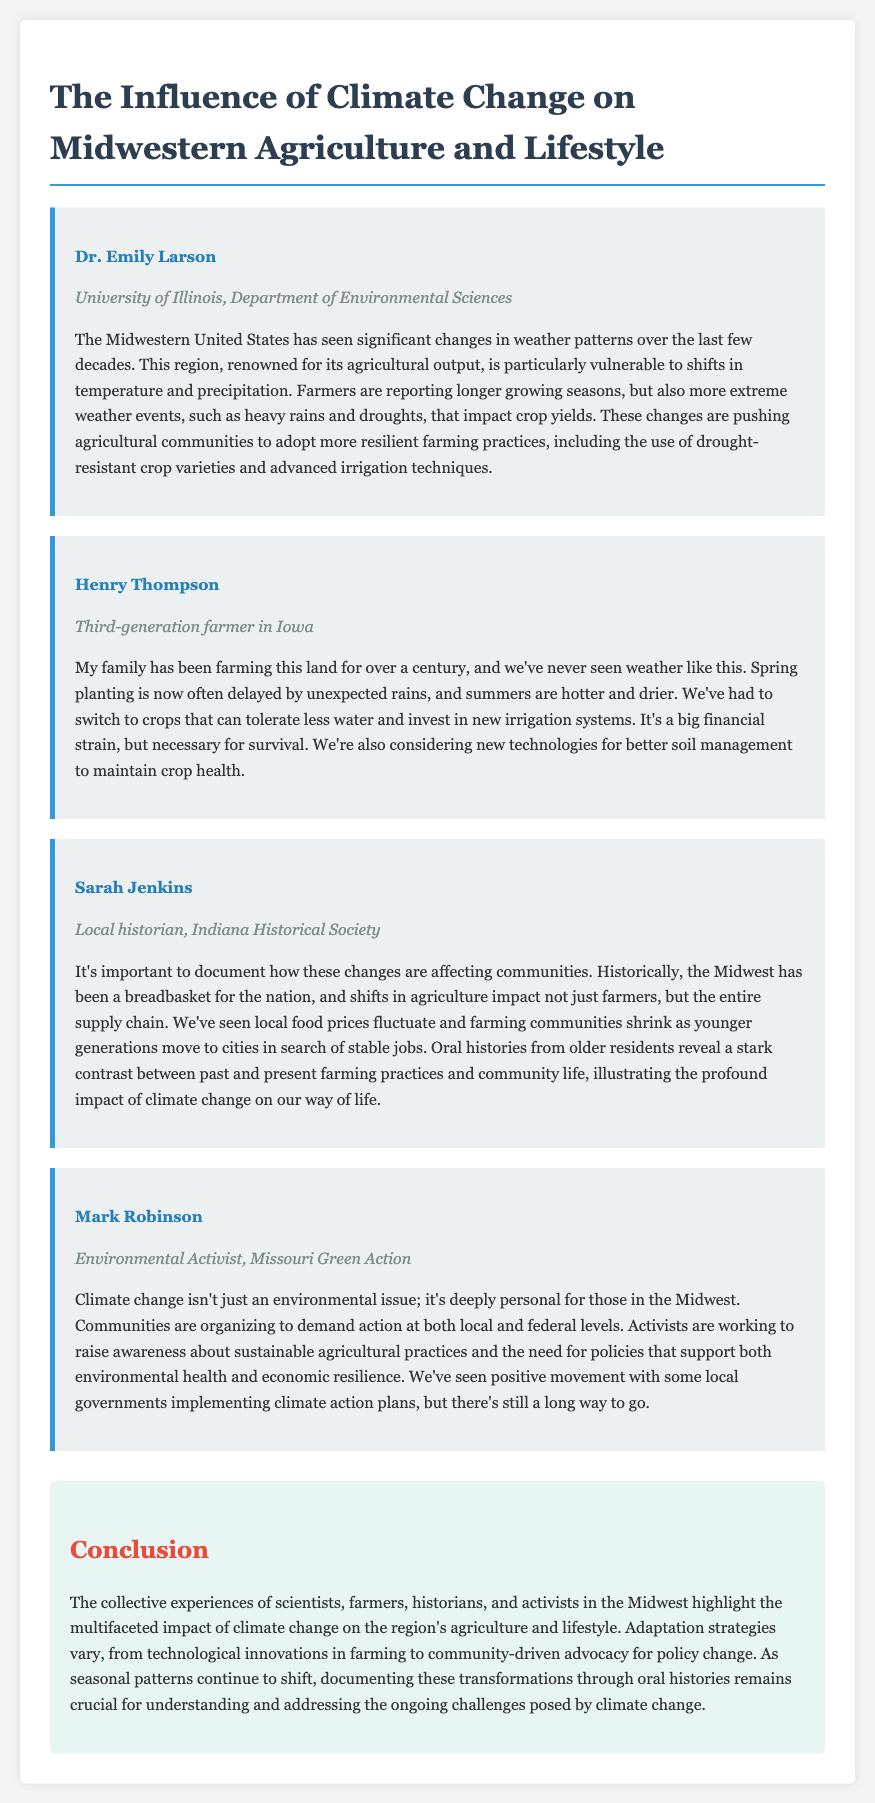What is the primary focus of the document? The document discusses the impact of climate change on agriculture and lifestyle in the Midwest.
Answer: Climate change on Midwestern agriculture and lifestyle Who is affiliated with the University of Illinois? Dr. Emily Larson is associated with the University of Illinois, Department of Environmental Sciences.
Answer: Dr. Emily Larson What are farmers reporting about growing seasons? Farmers are experiencing longer growing seasons but more extreme weather events.
Answer: Longer growing seasons What crop adaptation strategy is mentioned by Henry Thompson? Henry Thompson mentions switching to drought-resistant crop varieties.
Answer: Drought-resistant crop varieties How are local food prices affected by climate change, according to Sarah Jenkins? Local food prices fluctuate due to changes in agriculture.
Answer: Fluctuate What is the role of environmental activists in the Midwest regarding climate change? Environmental activists are raising awareness about sustainable agricultural practices.
Answer: Raising awareness about sustainable agricultural practices 